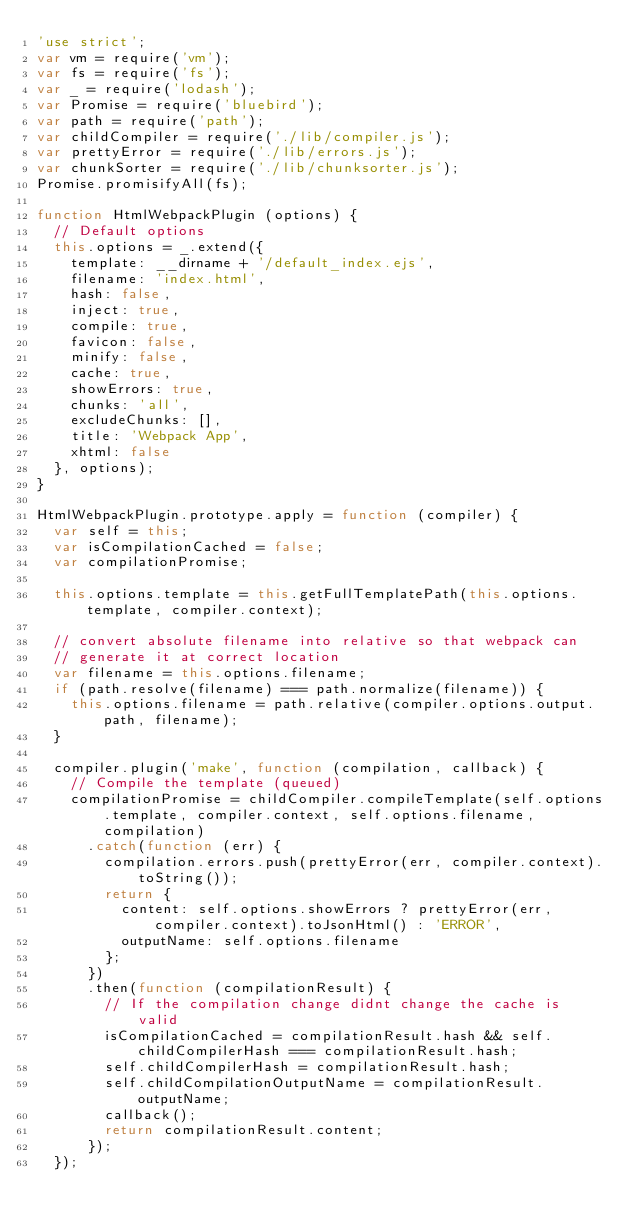Convert code to text. <code><loc_0><loc_0><loc_500><loc_500><_JavaScript_>'use strict';
var vm = require('vm');
var fs = require('fs');
var _ = require('lodash');
var Promise = require('bluebird');
var path = require('path');
var childCompiler = require('./lib/compiler.js');
var prettyError = require('./lib/errors.js');
var chunkSorter = require('./lib/chunksorter.js');
Promise.promisifyAll(fs);

function HtmlWebpackPlugin (options) {
  // Default options
  this.options = _.extend({
    template: __dirname + '/default_index.ejs',
    filename: 'index.html',
    hash: false,
    inject: true,
    compile: true,
    favicon: false,
    minify: false,
    cache: true,
    showErrors: true,
    chunks: 'all',
    excludeChunks: [],
    title: 'Webpack App',
    xhtml: false
  }, options);
}

HtmlWebpackPlugin.prototype.apply = function (compiler) {
  var self = this;
  var isCompilationCached = false;
  var compilationPromise;

  this.options.template = this.getFullTemplatePath(this.options.template, compiler.context);

  // convert absolute filename into relative so that webpack can
  // generate it at correct location
  var filename = this.options.filename;
  if (path.resolve(filename) === path.normalize(filename)) {
    this.options.filename = path.relative(compiler.options.output.path, filename);
  }

  compiler.plugin('make', function (compilation, callback) {
    // Compile the template (queued)
    compilationPromise = childCompiler.compileTemplate(self.options.template, compiler.context, self.options.filename, compilation)
      .catch(function (err) {
        compilation.errors.push(prettyError(err, compiler.context).toString());
        return {
          content: self.options.showErrors ? prettyError(err, compiler.context).toJsonHtml() : 'ERROR',
          outputName: self.options.filename
        };
      })
      .then(function (compilationResult) {
        // If the compilation change didnt change the cache is valid
        isCompilationCached = compilationResult.hash && self.childCompilerHash === compilationResult.hash;
        self.childCompilerHash = compilationResult.hash;
        self.childCompilationOutputName = compilationResult.outputName;
        callback();
        return compilationResult.content;
      });
  });
</code> 